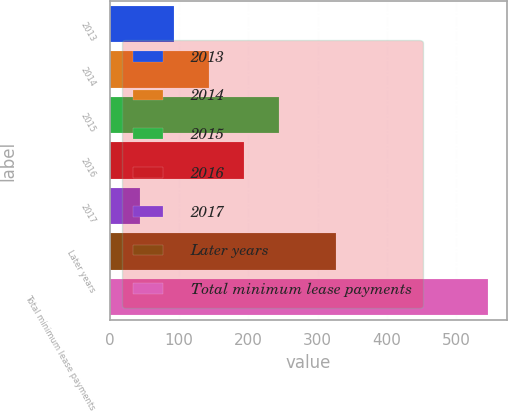Convert chart to OTSL. <chart><loc_0><loc_0><loc_500><loc_500><bar_chart><fcel>2013<fcel>2014<fcel>2015<fcel>2016<fcel>2017<fcel>Later years<fcel>Total minimum lease payments<nl><fcel>93.3<fcel>143.6<fcel>244.2<fcel>193.9<fcel>43<fcel>326<fcel>546<nl></chart> 